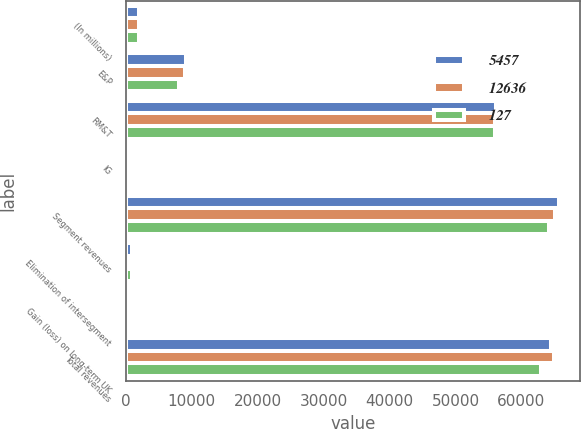<chart> <loc_0><loc_0><loc_500><loc_500><stacked_bar_chart><ecel><fcel>(In millions)<fcel>E&P<fcel>RM&T<fcel>IG<fcel>Segment revenues<fcel>Elimination of intersegment<fcel>Gain (loss) on long-term UK<fcel>Total revenues<nl><fcel>5457<fcel>2007<fcel>9155<fcel>56075<fcel>218<fcel>65669<fcel>885<fcel>232<fcel>64552<nl><fcel>12636<fcel>2006<fcel>9010<fcel>55941<fcel>179<fcel>65130<fcel>688<fcel>454<fcel>64896<nl><fcel>127<fcel>2005<fcel>8009<fcel>56003<fcel>236<fcel>64248<fcel>876<fcel>386<fcel>62986<nl></chart> 